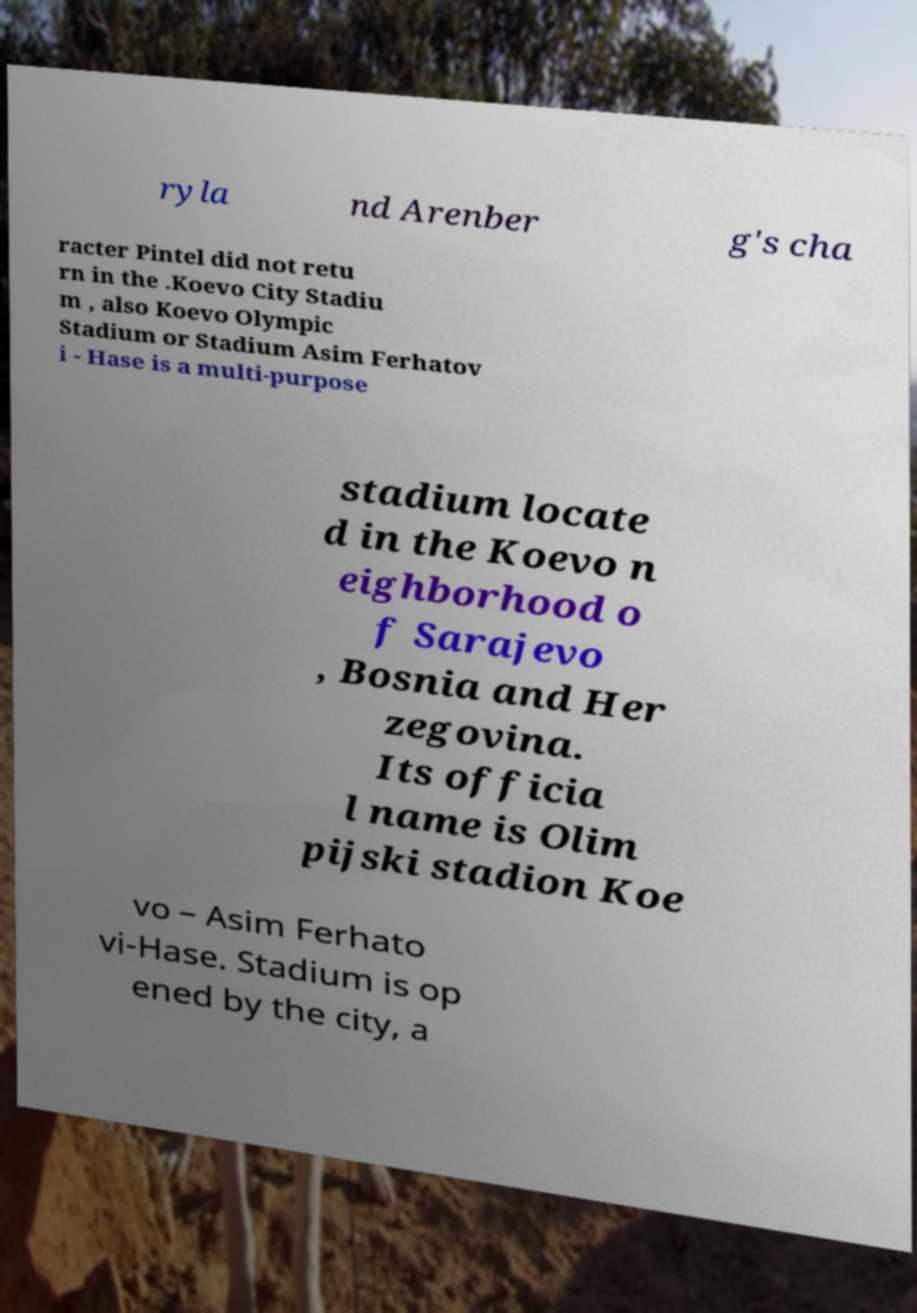Please identify and transcribe the text found in this image. ryla nd Arenber g's cha racter Pintel did not retu rn in the .Koevo City Stadiu m , also Koevo Olympic Stadium or Stadium Asim Ferhatov i - Hase is a multi-purpose stadium locate d in the Koevo n eighborhood o f Sarajevo , Bosnia and Her zegovina. Its officia l name is Olim pijski stadion Koe vo – Asim Ferhato vi-Hase. Stadium is op ened by the city, a 